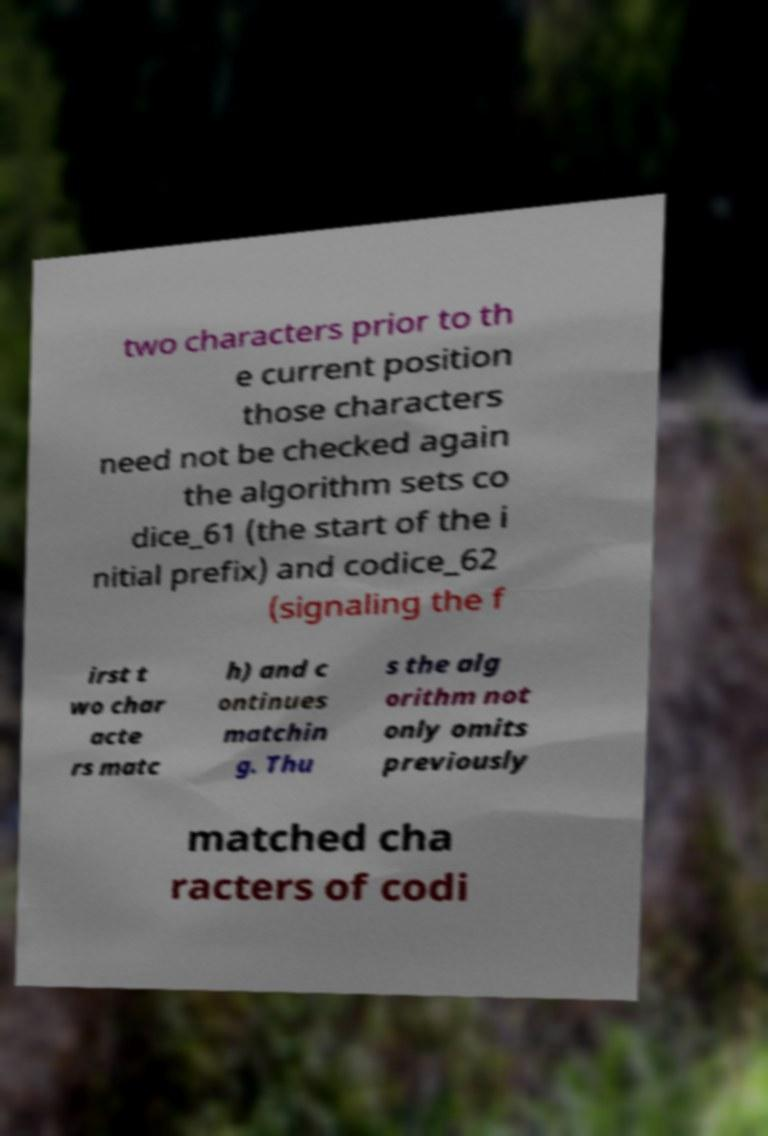There's text embedded in this image that I need extracted. Can you transcribe it verbatim? two characters prior to th e current position those characters need not be checked again the algorithm sets co dice_61 (the start of the i nitial prefix) and codice_62 (signaling the f irst t wo char acte rs matc h) and c ontinues matchin g. Thu s the alg orithm not only omits previously matched cha racters of codi 